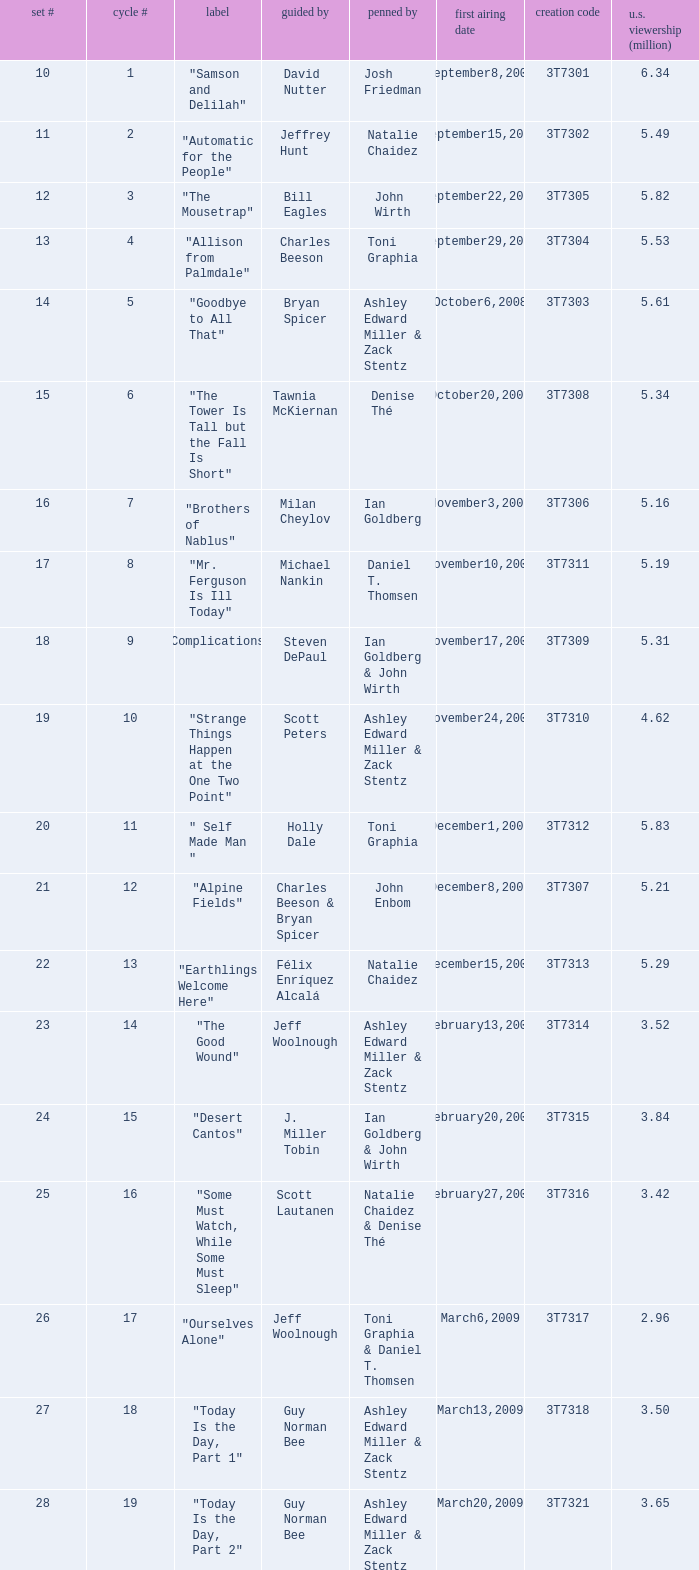How many viewers did the episode directed by David Nutter draw in? 6.34. 